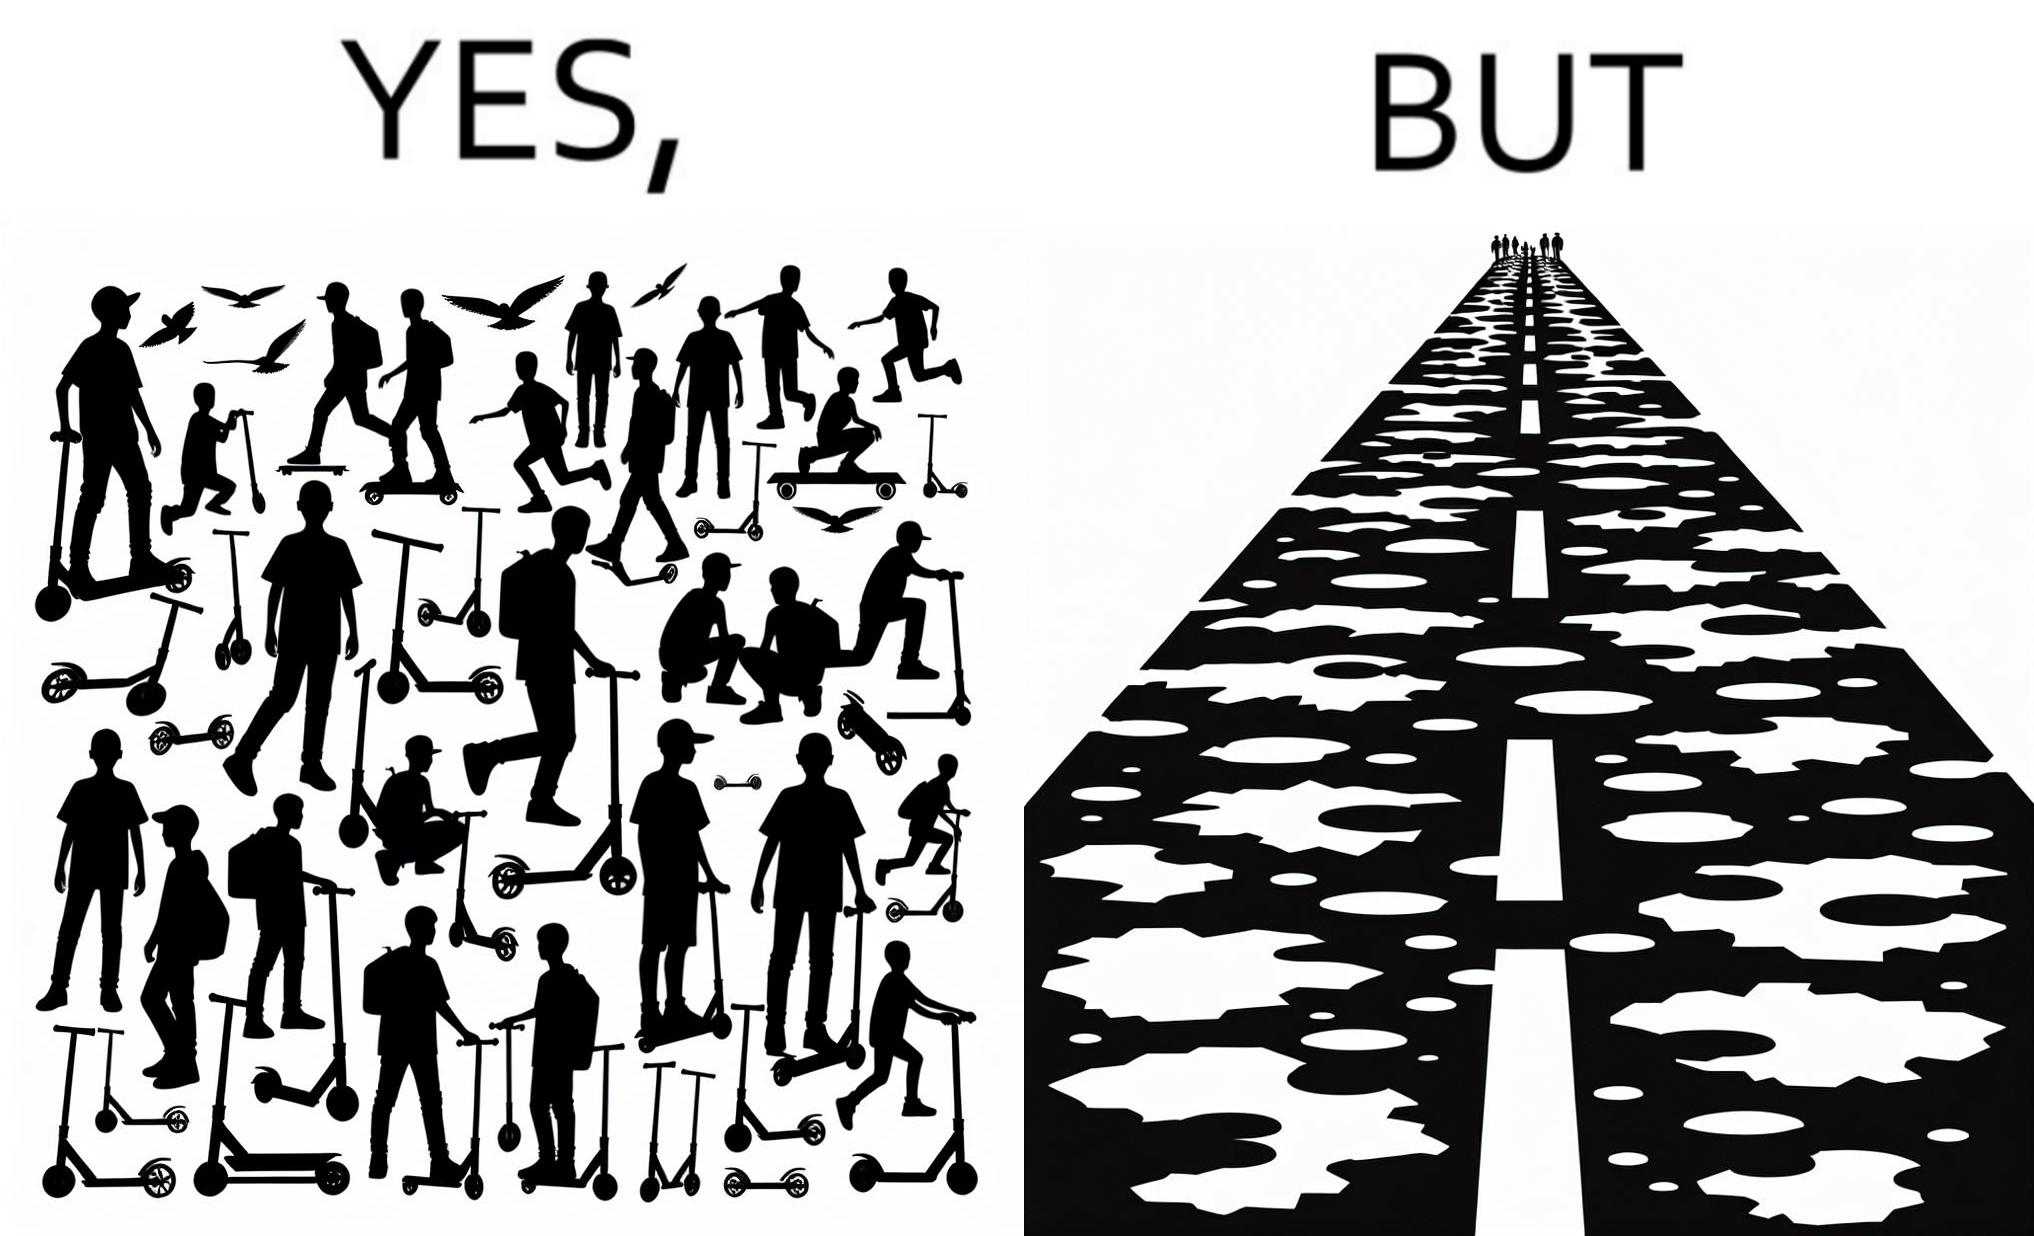Why is this image considered satirical? The image is ironic, because even after when the skateboard scooters are available for someone to ride but the road has many potholes that it is not suitable to ride the scooters on such roads 